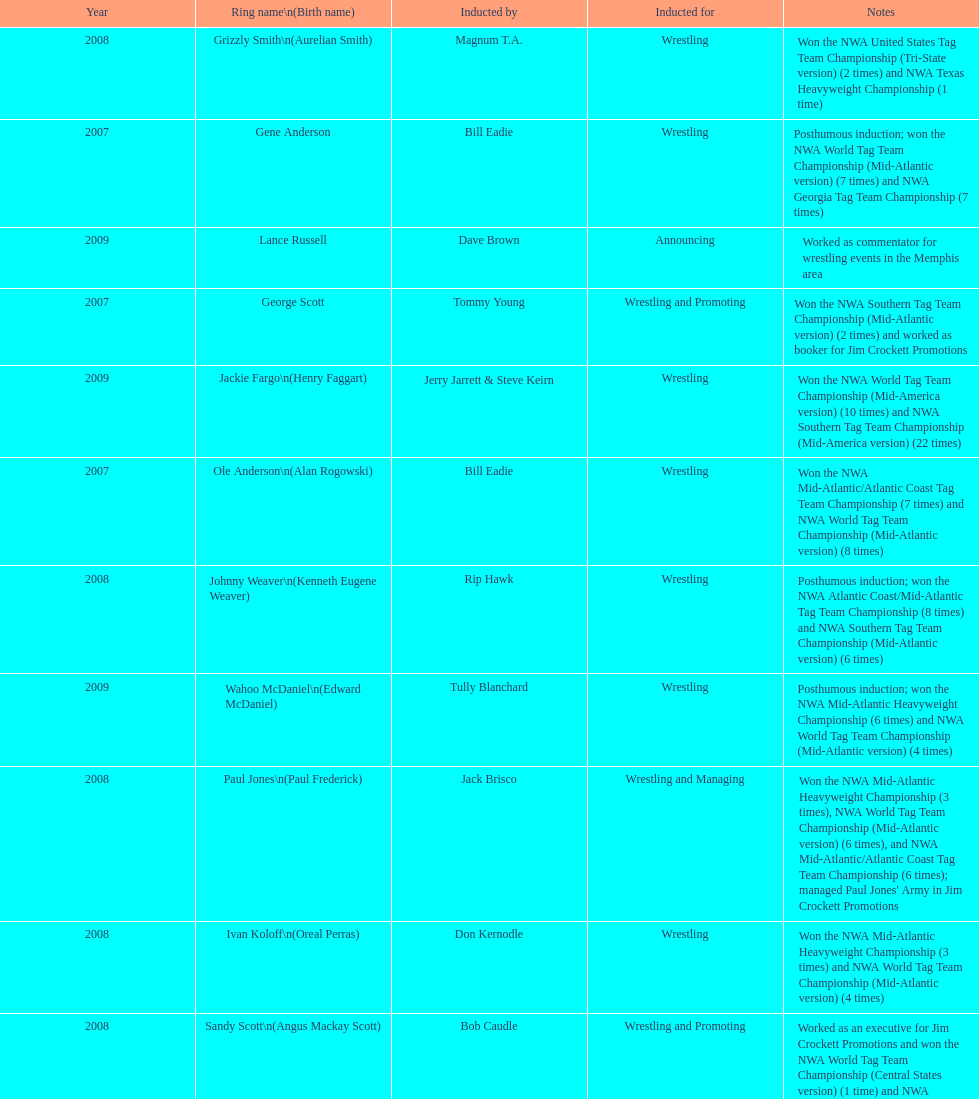Who was the only person to be inducted for wrestling and managing? Paul Jones. 